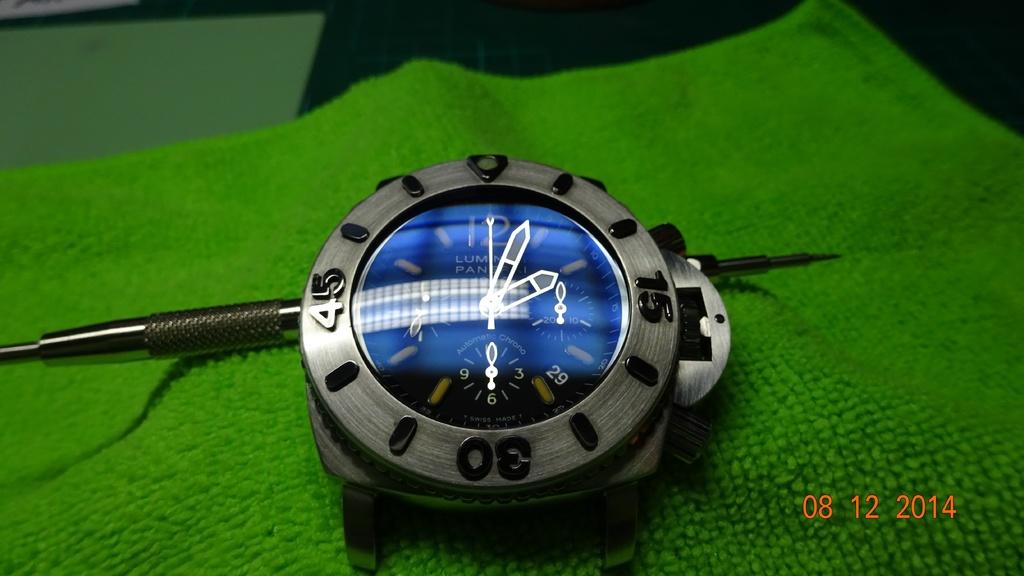What date is the photo from?
Your answer should be very brief. 08 12 2014. What number is on the bottom dial?
Provide a short and direct response. 30. 